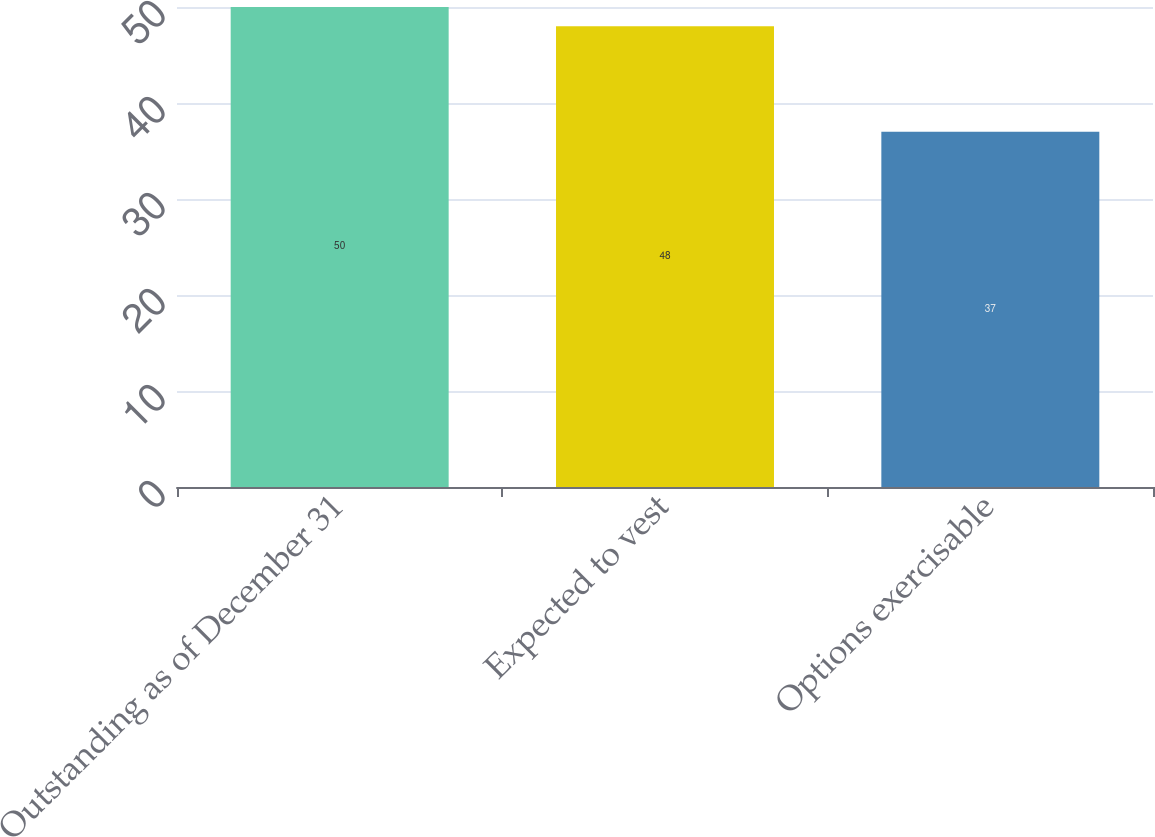Convert chart. <chart><loc_0><loc_0><loc_500><loc_500><bar_chart><fcel>Outstanding as of December 31<fcel>Expected to vest<fcel>Options exercisable<nl><fcel>50<fcel>48<fcel>37<nl></chart> 